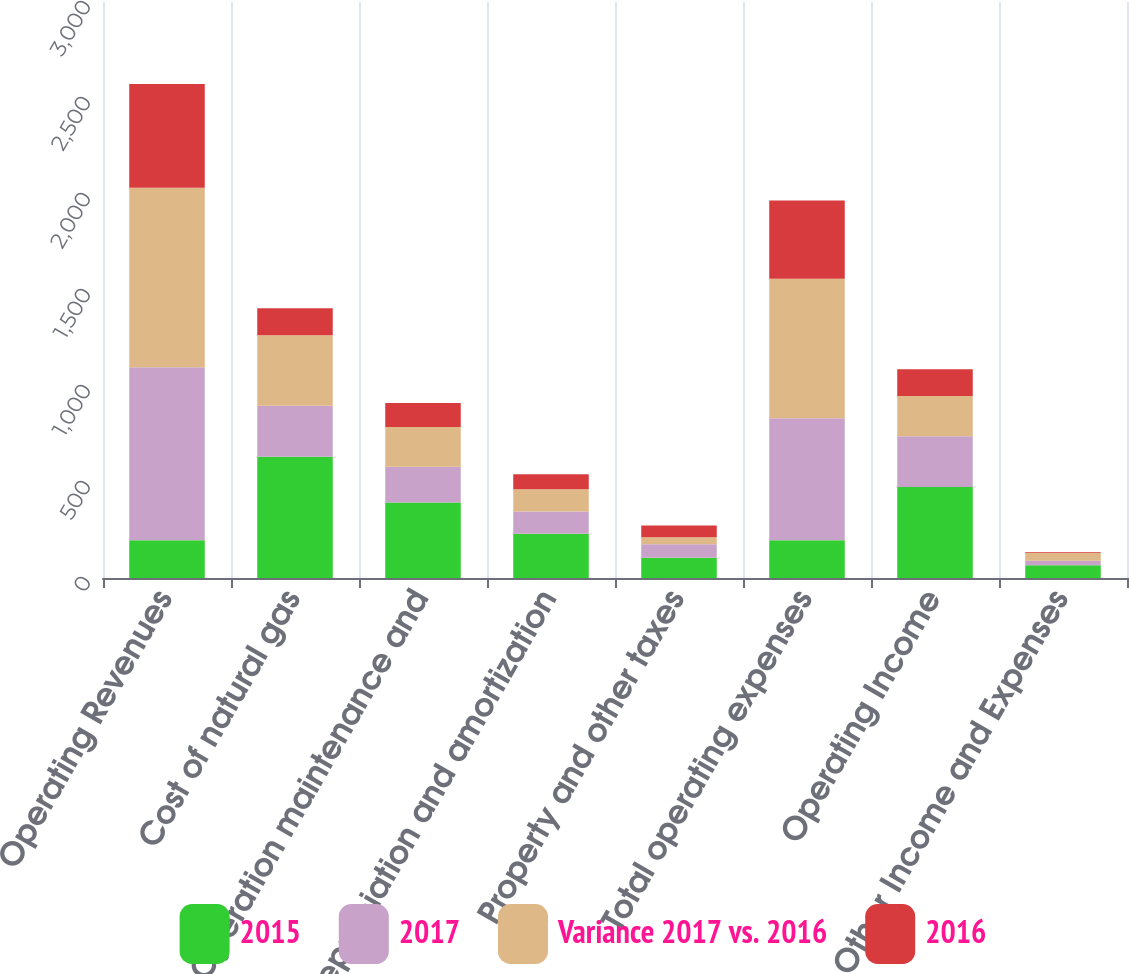Convert chart to OTSL. <chart><loc_0><loc_0><loc_500><loc_500><stacked_bar_chart><ecel><fcel>Operating Revenues<fcel>Cost of natural gas<fcel>Operation maintenance and<fcel>Depreciation and amortization<fcel>Property and other taxes<fcel>Total operating expenses<fcel>Operating Income<fcel>Other Income and Expenses<nl><fcel>2015<fcel>196.5<fcel>632<fcel>393<fcel>231<fcel>106<fcel>196.5<fcel>474<fcel>66<nl><fcel>2017<fcel>901<fcel>265<fcel>186<fcel>115<fcel>70<fcel>636<fcel>264<fcel>24<nl><fcel>Variance 2017 vs. 2016<fcel>935<fcel>367<fcel>207<fcel>116<fcel>36<fcel>726<fcel>210<fcel>42<nl><fcel>2016<fcel>541<fcel>141<fcel>126<fcel>79<fcel>62<fcel>408<fcel>139<fcel>3<nl></chart> 